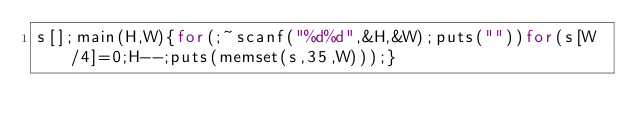<code> <loc_0><loc_0><loc_500><loc_500><_C_>s[];main(H,W){for(;~scanf("%d%d",&H,&W);puts(""))for(s[W/4]=0;H--;puts(memset(s,35,W)));}</code> 